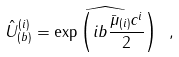Convert formula to latex. <formula><loc_0><loc_0><loc_500><loc_500>\hat { U } ^ { ( i ) } _ { ( b ) } = \widehat { \exp \left ( i b \frac { \bar { \mu } _ { ( i ) } c ^ { i } } { 2 } \right ) } \ ,</formula> 